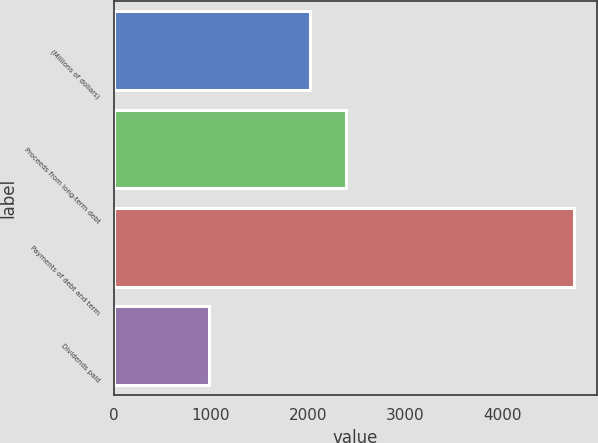Convert chart to OTSL. <chart><loc_0><loc_0><loc_500><loc_500><bar_chart><fcel>(Millions of dollars)<fcel>Proceeds from long-term debt<fcel>Payments of debt and term<fcel>Dividends paid<nl><fcel>2019<fcel>2395<fcel>4744<fcel>984<nl></chart> 